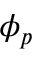Convert formula to latex. <formula><loc_0><loc_0><loc_500><loc_500>\phi _ { p }</formula> 